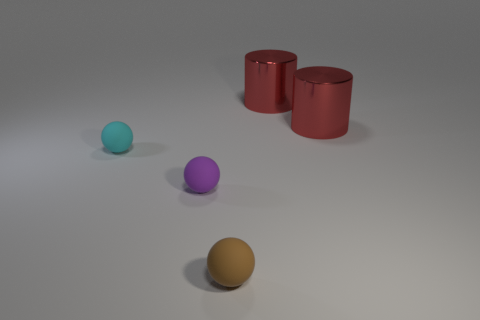There is a small ball that is behind the tiny brown object and to the right of the small cyan rubber sphere; what is its color?
Ensure brevity in your answer.  Purple. There is a cyan thing that is the same size as the brown ball; what is its shape?
Provide a short and direct response. Sphere. Are there the same number of purple matte balls right of the brown matte ball and large purple metal balls?
Offer a very short reply. Yes. What number of cyan spheres have the same material as the brown sphere?
Keep it short and to the point. 1. Are there an equal number of things that are right of the brown rubber ball and metal cylinders on the right side of the purple matte sphere?
Ensure brevity in your answer.  Yes. Is the number of small objects behind the brown rubber object greater than the number of cylinders on the left side of the tiny cyan thing?
Provide a succinct answer. Yes. There is a purple matte ball; are there any rubber spheres in front of it?
Offer a very short reply. Yes. What is the material of the small thing that is to the left of the small brown matte thing and on the right side of the small cyan matte object?
Make the answer very short. Rubber. There is a thing in front of the purple object; are there any small cyan matte things that are behind it?
Provide a succinct answer. Yes. The purple object is what size?
Provide a short and direct response. Small. 